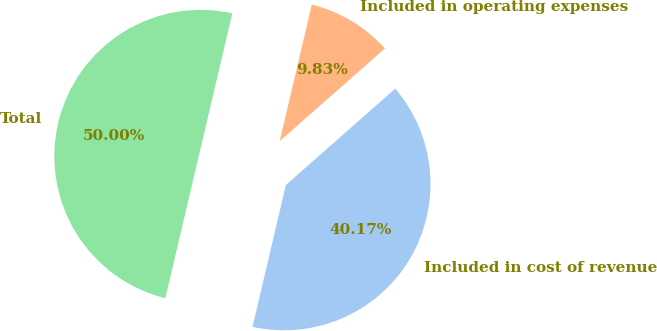<chart> <loc_0><loc_0><loc_500><loc_500><pie_chart><fcel>Included in cost of revenue<fcel>Included in operating expenses<fcel>Total<nl><fcel>40.17%<fcel>9.83%<fcel>50.0%<nl></chart> 